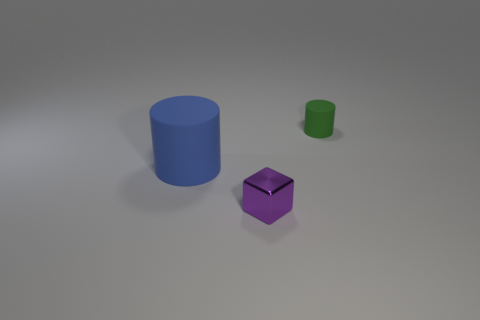Add 1 small purple metal cubes. How many objects exist? 4 Subtract all blue cylinders. Subtract all small metallic objects. How many objects are left? 1 Add 2 big blue matte things. How many big blue matte things are left? 3 Add 2 large purple cubes. How many large purple cubes exist? 2 Subtract 1 blue cylinders. How many objects are left? 2 Subtract all cylinders. How many objects are left? 1 Subtract all cyan cylinders. Subtract all red cubes. How many cylinders are left? 2 